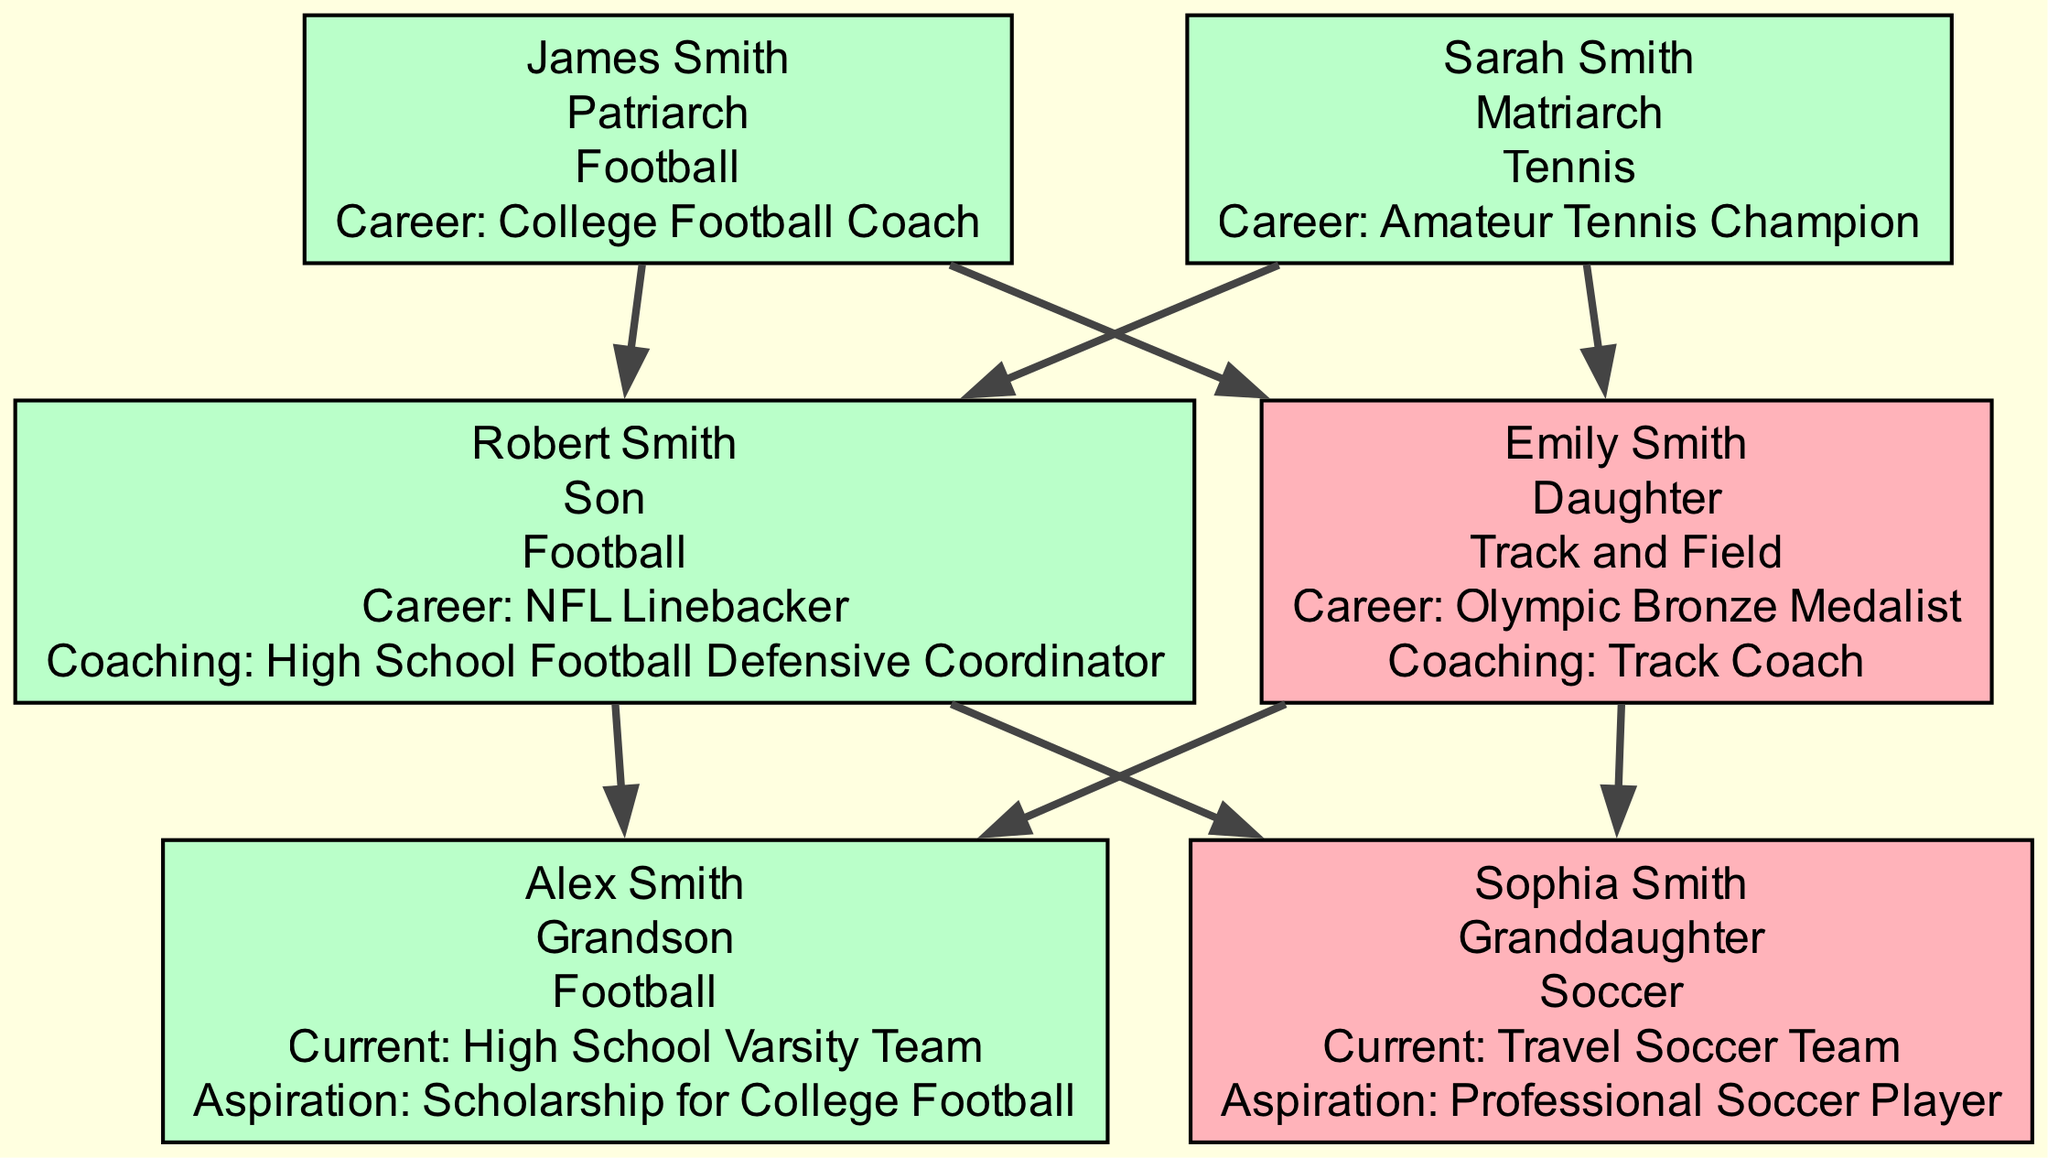What is James Smith's sports involvement? James Smith is listed in the first generation as being involved in "Football." This information is found directly in the description of his member node in the diagram.
Answer: Football Who is the Olympic Bronze Medalist in the family? Emily Smith, mentioned in the second generation, is identified as the "Olympic Bronze Medalist" in her career highlights. This can be found directly in her member node.
Answer: Emily Smith What role does Robert Smith hold apart from being an NFL Linebacker? Robert Smith's node indicates that in addition to being an NFL Linebacker, he is also the "High School Football Defensive Coordinator." This information combines his sports involvement and coaching roles in his member description.
Answer: High School Football Defensive Coordinator What is Alex Smith's current aspiration? Alex Smith, in the third generation, has stated the aspiration of obtaining a "Scholarship for College Football," which is a part of his member description. This is a specific goal related to his current involvement in football.
Answer: Scholarship for College Football How many generations are represented in the family tree? The diagram details three distinct generations, each containing members with specified roles, sports involvement, and highlights. This can be counted directly from the generations listed in the data structure.
Answer: 3 Which family member is involved in soccer? Sophia Smith, who is a granddaughter in the third generation, is noted to be involved in "Soccer." This is listed in her member node alongside her aspirations for a professional career in soccer.
Answer: Sophia Smith What sports do Robert and Emily Smith have in common? Both Robert Smith and Emily Smith are involved in sports; however, they do not share a common sport as Robert is involved in football and Emily in track and field. This requires analyzing their sports involvement in the diagram.
Answer: None Who is the matriarch of the family? Sarah Smith is identified as the "Matriarch" in the first generation in the diagram, thus fulfilling the role of the family matriarch. This information is directly provided in her member description.
Answer: Sarah Smith What coaching role does Emily Smith serve? Emily Smith is noted to serve as a "Track Coach" in her member description. This denotes her involvement beyond just competing in her sport, indicating her commitment to mentorship and coaching.
Answer: Track Coach 